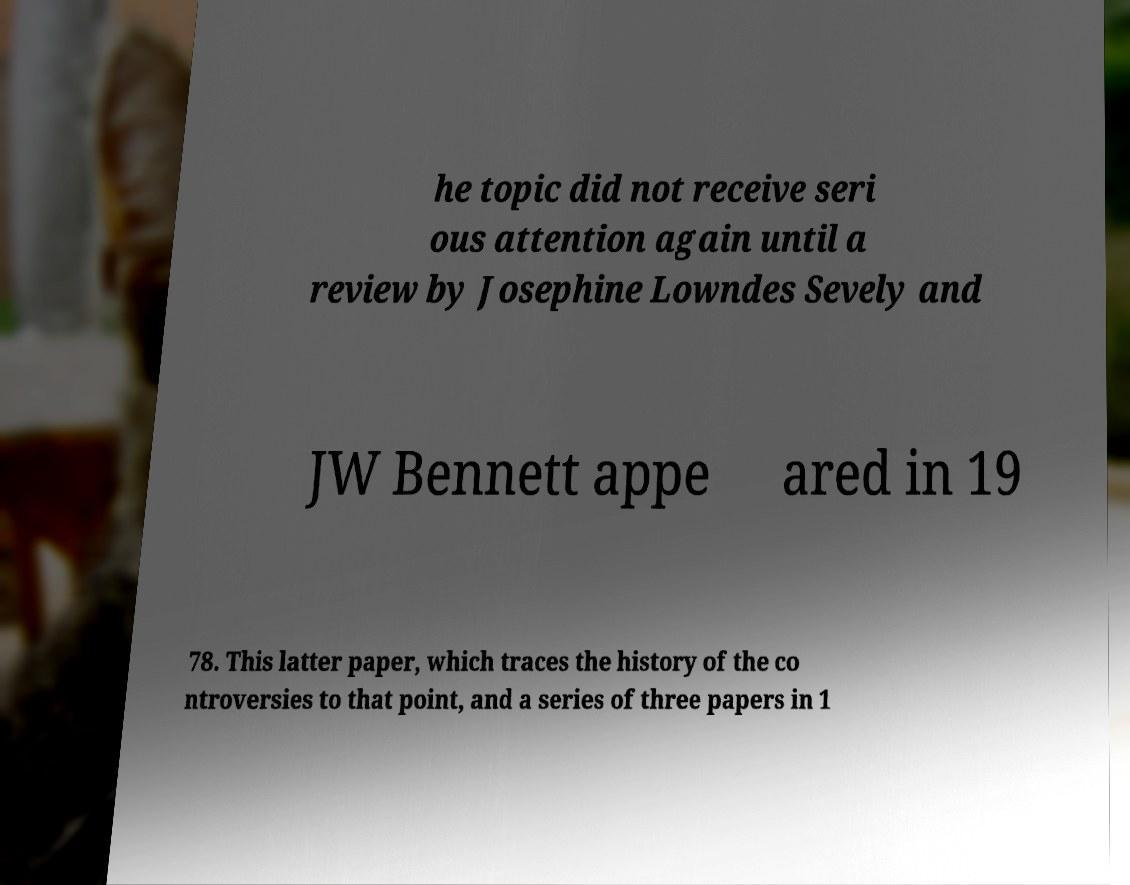Please identify and transcribe the text found in this image. he topic did not receive seri ous attention again until a review by Josephine Lowndes Sevely and JW Bennett appe ared in 19 78. This latter paper, which traces the history of the co ntroversies to that point, and a series of three papers in 1 